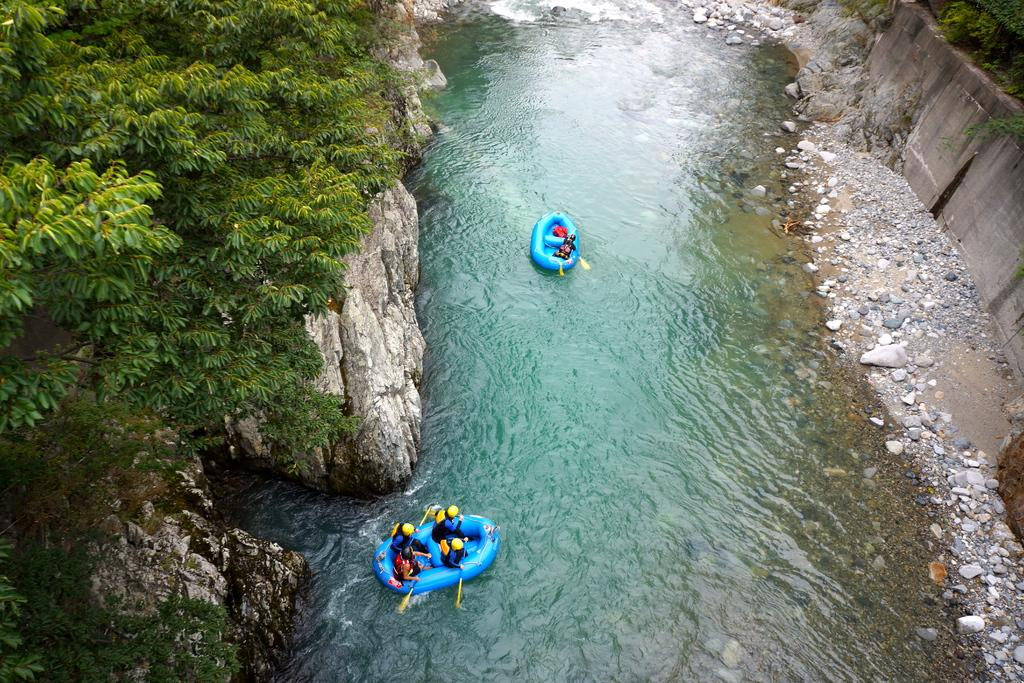How many boats are in the image? There are two blue color boats in the image. Where are the boats located? The boats are in a lake. What else can be seen in the image besides the boats? There are stones and trees visible in the image. What is the size of the knee of the person in the image? There is no person present in the image, so it is not possible to determine the size of their knee. 